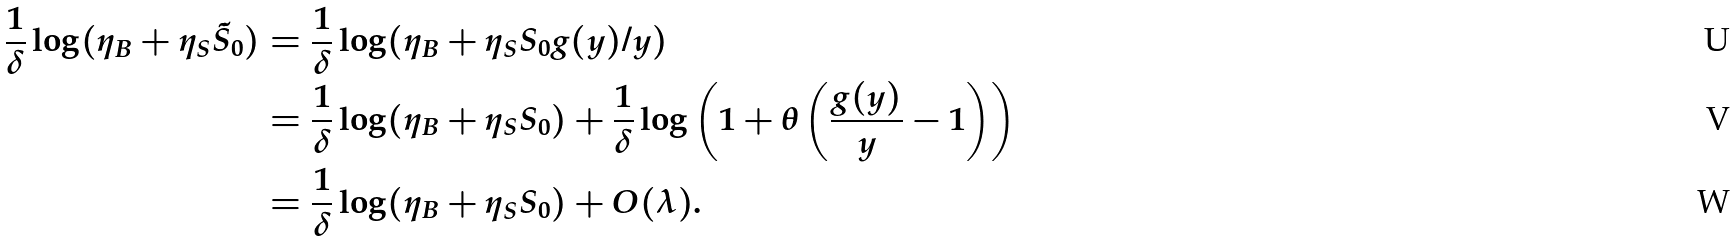Convert formula to latex. <formula><loc_0><loc_0><loc_500><loc_500>\frac { 1 } { \delta } \log ( \eta _ { B } + \eta _ { S } \tilde { S } _ { 0 } ) & = \frac { 1 } { \delta } \log ( \eta _ { B } + \eta _ { S } S _ { 0 } g ( y ) / y ) \\ & = \frac { 1 } { \delta } \log ( \eta _ { B } + \eta _ { S } S _ { 0 } ) + \frac { 1 } { \delta } \log \left ( 1 + \theta \left ( \frac { g ( y ) } { y } - 1 \right ) \right ) \\ & = \frac { 1 } { \delta } \log ( \eta _ { B } + \eta _ { S } S _ { 0 } ) + O ( \lambda ) .</formula> 